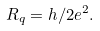<formula> <loc_0><loc_0><loc_500><loc_500>R _ { q } = h / 2 e ^ { 2 } .</formula> 